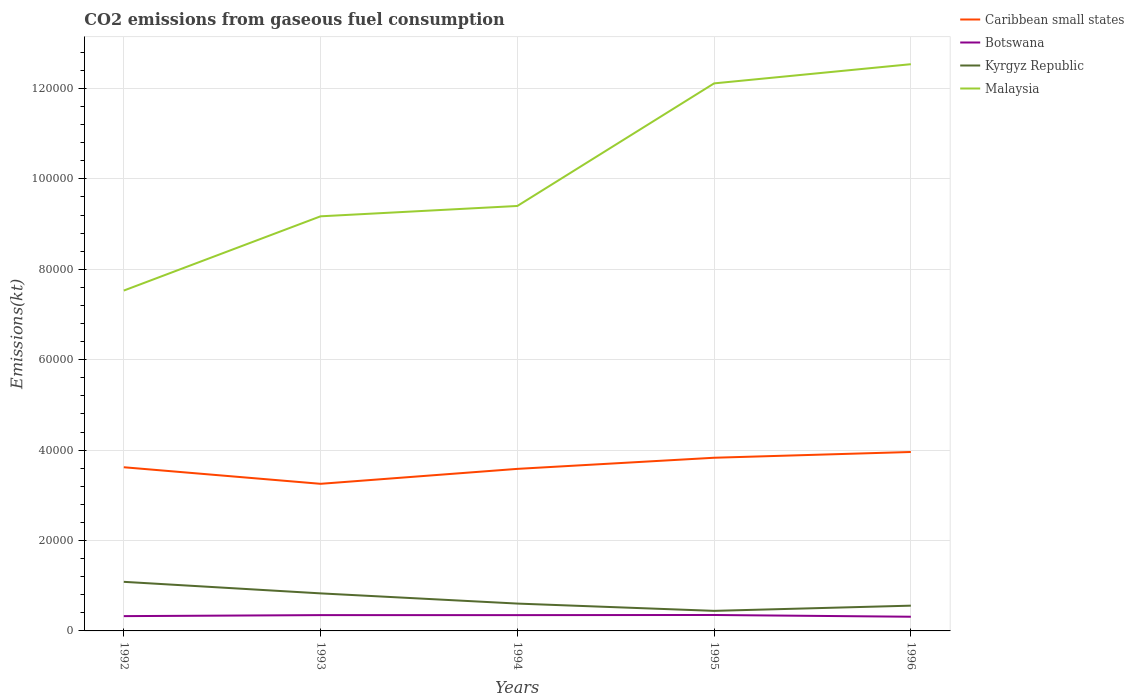How many different coloured lines are there?
Provide a succinct answer. 4. Is the number of lines equal to the number of legend labels?
Offer a terse response. Yes. Across all years, what is the maximum amount of CO2 emitted in Botswana?
Provide a short and direct response. 3138.95. What is the total amount of CO2 emitted in Botswana in the graph?
Provide a succinct answer. -25.67. What is the difference between the highest and the second highest amount of CO2 emitted in Kyrgyz Republic?
Your response must be concise. 6424.58. How many lines are there?
Offer a very short reply. 4. Does the graph contain any zero values?
Your answer should be very brief. No. Does the graph contain grids?
Ensure brevity in your answer.  Yes. Where does the legend appear in the graph?
Your answer should be very brief. Top right. How are the legend labels stacked?
Offer a terse response. Vertical. What is the title of the graph?
Keep it short and to the point. CO2 emissions from gaseous fuel consumption. What is the label or title of the Y-axis?
Give a very brief answer. Emissions(kt). What is the Emissions(kt) of Caribbean small states in 1992?
Your response must be concise. 3.62e+04. What is the Emissions(kt) in Botswana in 1992?
Make the answer very short. 3274.63. What is the Emissions(kt) in Kyrgyz Republic in 1992?
Offer a very short reply. 1.09e+04. What is the Emissions(kt) in Malaysia in 1992?
Offer a terse response. 7.53e+04. What is the Emissions(kt) in Caribbean small states in 1993?
Provide a short and direct response. 3.25e+04. What is the Emissions(kt) of Botswana in 1993?
Provide a short and direct response. 3498.32. What is the Emissions(kt) in Kyrgyz Republic in 1993?
Offer a terse response. 8305.75. What is the Emissions(kt) of Malaysia in 1993?
Your response must be concise. 9.17e+04. What is the Emissions(kt) in Caribbean small states in 1994?
Provide a short and direct response. 3.58e+04. What is the Emissions(kt) of Botswana in 1994?
Keep it short and to the point. 3494.65. What is the Emissions(kt) of Kyrgyz Republic in 1994?
Give a very brief answer. 6050.55. What is the Emissions(kt) of Malaysia in 1994?
Provide a short and direct response. 9.40e+04. What is the Emissions(kt) of Caribbean small states in 1995?
Your answer should be compact. 3.83e+04. What is the Emissions(kt) of Botswana in 1995?
Provide a short and direct response. 3523.99. What is the Emissions(kt) of Kyrgyz Republic in 1995?
Ensure brevity in your answer.  4437.07. What is the Emissions(kt) of Malaysia in 1995?
Provide a short and direct response. 1.21e+05. What is the Emissions(kt) of Caribbean small states in 1996?
Keep it short and to the point. 3.96e+04. What is the Emissions(kt) of Botswana in 1996?
Provide a short and direct response. 3138.95. What is the Emissions(kt) of Kyrgyz Republic in 1996?
Your answer should be compact. 5588.51. What is the Emissions(kt) in Malaysia in 1996?
Your answer should be very brief. 1.25e+05. Across all years, what is the maximum Emissions(kt) of Caribbean small states?
Give a very brief answer. 3.96e+04. Across all years, what is the maximum Emissions(kt) of Botswana?
Your response must be concise. 3523.99. Across all years, what is the maximum Emissions(kt) of Kyrgyz Republic?
Offer a terse response. 1.09e+04. Across all years, what is the maximum Emissions(kt) in Malaysia?
Your response must be concise. 1.25e+05. Across all years, what is the minimum Emissions(kt) in Caribbean small states?
Your answer should be compact. 3.25e+04. Across all years, what is the minimum Emissions(kt) of Botswana?
Provide a short and direct response. 3138.95. Across all years, what is the minimum Emissions(kt) of Kyrgyz Republic?
Offer a terse response. 4437.07. Across all years, what is the minimum Emissions(kt) in Malaysia?
Your response must be concise. 7.53e+04. What is the total Emissions(kt) of Caribbean small states in the graph?
Give a very brief answer. 1.82e+05. What is the total Emissions(kt) of Botswana in the graph?
Your answer should be very brief. 1.69e+04. What is the total Emissions(kt) of Kyrgyz Republic in the graph?
Provide a succinct answer. 3.52e+04. What is the total Emissions(kt) of Malaysia in the graph?
Make the answer very short. 5.08e+05. What is the difference between the Emissions(kt) in Caribbean small states in 1992 and that in 1993?
Ensure brevity in your answer.  3663.33. What is the difference between the Emissions(kt) of Botswana in 1992 and that in 1993?
Keep it short and to the point. -223.69. What is the difference between the Emissions(kt) in Kyrgyz Republic in 1992 and that in 1993?
Offer a very short reply. 2555.9. What is the difference between the Emissions(kt) in Malaysia in 1992 and that in 1993?
Keep it short and to the point. -1.64e+04. What is the difference between the Emissions(kt) of Caribbean small states in 1992 and that in 1994?
Provide a short and direct response. 359.37. What is the difference between the Emissions(kt) in Botswana in 1992 and that in 1994?
Provide a short and direct response. -220.02. What is the difference between the Emissions(kt) of Kyrgyz Republic in 1992 and that in 1994?
Your response must be concise. 4811.1. What is the difference between the Emissions(kt) of Malaysia in 1992 and that in 1994?
Your response must be concise. -1.87e+04. What is the difference between the Emissions(kt) of Caribbean small states in 1992 and that in 1995?
Give a very brief answer. -2101.19. What is the difference between the Emissions(kt) in Botswana in 1992 and that in 1995?
Provide a short and direct response. -249.36. What is the difference between the Emissions(kt) in Kyrgyz Republic in 1992 and that in 1995?
Make the answer very short. 6424.58. What is the difference between the Emissions(kt) of Malaysia in 1992 and that in 1995?
Your answer should be compact. -4.58e+04. What is the difference between the Emissions(kt) in Caribbean small states in 1992 and that in 1996?
Offer a very short reply. -3377.31. What is the difference between the Emissions(kt) of Botswana in 1992 and that in 1996?
Make the answer very short. 135.68. What is the difference between the Emissions(kt) of Kyrgyz Republic in 1992 and that in 1996?
Offer a very short reply. 5273.15. What is the difference between the Emissions(kt) of Malaysia in 1992 and that in 1996?
Make the answer very short. -5.01e+04. What is the difference between the Emissions(kt) of Caribbean small states in 1993 and that in 1994?
Offer a very short reply. -3303.97. What is the difference between the Emissions(kt) of Botswana in 1993 and that in 1994?
Give a very brief answer. 3.67. What is the difference between the Emissions(kt) of Kyrgyz Republic in 1993 and that in 1994?
Provide a succinct answer. 2255.2. What is the difference between the Emissions(kt) of Malaysia in 1993 and that in 1994?
Your answer should be very brief. -2288.21. What is the difference between the Emissions(kt) in Caribbean small states in 1993 and that in 1995?
Provide a succinct answer. -5764.52. What is the difference between the Emissions(kt) of Botswana in 1993 and that in 1995?
Provide a succinct answer. -25.67. What is the difference between the Emissions(kt) in Kyrgyz Republic in 1993 and that in 1995?
Provide a short and direct response. 3868.68. What is the difference between the Emissions(kt) of Malaysia in 1993 and that in 1995?
Your answer should be very brief. -2.94e+04. What is the difference between the Emissions(kt) in Caribbean small states in 1993 and that in 1996?
Provide a short and direct response. -7040.64. What is the difference between the Emissions(kt) in Botswana in 1993 and that in 1996?
Your answer should be compact. 359.37. What is the difference between the Emissions(kt) in Kyrgyz Republic in 1993 and that in 1996?
Your answer should be very brief. 2717.25. What is the difference between the Emissions(kt) in Malaysia in 1993 and that in 1996?
Offer a very short reply. -3.37e+04. What is the difference between the Emissions(kt) of Caribbean small states in 1994 and that in 1995?
Keep it short and to the point. -2460.56. What is the difference between the Emissions(kt) of Botswana in 1994 and that in 1995?
Offer a very short reply. -29.34. What is the difference between the Emissions(kt) in Kyrgyz Republic in 1994 and that in 1995?
Your response must be concise. 1613.48. What is the difference between the Emissions(kt) in Malaysia in 1994 and that in 1995?
Your answer should be very brief. -2.71e+04. What is the difference between the Emissions(kt) of Caribbean small states in 1994 and that in 1996?
Provide a short and direct response. -3736.67. What is the difference between the Emissions(kt) of Botswana in 1994 and that in 1996?
Keep it short and to the point. 355.7. What is the difference between the Emissions(kt) in Kyrgyz Republic in 1994 and that in 1996?
Keep it short and to the point. 462.04. What is the difference between the Emissions(kt) of Malaysia in 1994 and that in 1996?
Keep it short and to the point. -3.14e+04. What is the difference between the Emissions(kt) of Caribbean small states in 1995 and that in 1996?
Your answer should be very brief. -1276.12. What is the difference between the Emissions(kt) in Botswana in 1995 and that in 1996?
Provide a succinct answer. 385.04. What is the difference between the Emissions(kt) in Kyrgyz Republic in 1995 and that in 1996?
Provide a short and direct response. -1151.44. What is the difference between the Emissions(kt) of Malaysia in 1995 and that in 1996?
Provide a short and direct response. -4242.72. What is the difference between the Emissions(kt) in Caribbean small states in 1992 and the Emissions(kt) in Botswana in 1993?
Ensure brevity in your answer.  3.27e+04. What is the difference between the Emissions(kt) in Caribbean small states in 1992 and the Emissions(kt) in Kyrgyz Republic in 1993?
Offer a very short reply. 2.79e+04. What is the difference between the Emissions(kt) in Caribbean small states in 1992 and the Emissions(kt) in Malaysia in 1993?
Provide a short and direct response. -5.55e+04. What is the difference between the Emissions(kt) of Botswana in 1992 and the Emissions(kt) of Kyrgyz Republic in 1993?
Provide a succinct answer. -5031.12. What is the difference between the Emissions(kt) in Botswana in 1992 and the Emissions(kt) in Malaysia in 1993?
Make the answer very short. -8.84e+04. What is the difference between the Emissions(kt) in Kyrgyz Republic in 1992 and the Emissions(kt) in Malaysia in 1993?
Provide a short and direct response. -8.09e+04. What is the difference between the Emissions(kt) of Caribbean small states in 1992 and the Emissions(kt) of Botswana in 1994?
Offer a very short reply. 3.27e+04. What is the difference between the Emissions(kt) in Caribbean small states in 1992 and the Emissions(kt) in Kyrgyz Republic in 1994?
Your answer should be compact. 3.02e+04. What is the difference between the Emissions(kt) of Caribbean small states in 1992 and the Emissions(kt) of Malaysia in 1994?
Your response must be concise. -5.78e+04. What is the difference between the Emissions(kt) in Botswana in 1992 and the Emissions(kt) in Kyrgyz Republic in 1994?
Give a very brief answer. -2775.92. What is the difference between the Emissions(kt) of Botswana in 1992 and the Emissions(kt) of Malaysia in 1994?
Ensure brevity in your answer.  -9.07e+04. What is the difference between the Emissions(kt) in Kyrgyz Republic in 1992 and the Emissions(kt) in Malaysia in 1994?
Make the answer very short. -8.31e+04. What is the difference between the Emissions(kt) of Caribbean small states in 1992 and the Emissions(kt) of Botswana in 1995?
Keep it short and to the point. 3.27e+04. What is the difference between the Emissions(kt) of Caribbean small states in 1992 and the Emissions(kt) of Kyrgyz Republic in 1995?
Provide a succinct answer. 3.18e+04. What is the difference between the Emissions(kt) in Caribbean small states in 1992 and the Emissions(kt) in Malaysia in 1995?
Offer a terse response. -8.49e+04. What is the difference between the Emissions(kt) of Botswana in 1992 and the Emissions(kt) of Kyrgyz Republic in 1995?
Give a very brief answer. -1162.44. What is the difference between the Emissions(kt) in Botswana in 1992 and the Emissions(kt) in Malaysia in 1995?
Ensure brevity in your answer.  -1.18e+05. What is the difference between the Emissions(kt) of Kyrgyz Republic in 1992 and the Emissions(kt) of Malaysia in 1995?
Make the answer very short. -1.10e+05. What is the difference between the Emissions(kt) in Caribbean small states in 1992 and the Emissions(kt) in Botswana in 1996?
Your answer should be very brief. 3.31e+04. What is the difference between the Emissions(kt) of Caribbean small states in 1992 and the Emissions(kt) of Kyrgyz Republic in 1996?
Your response must be concise. 3.06e+04. What is the difference between the Emissions(kt) in Caribbean small states in 1992 and the Emissions(kt) in Malaysia in 1996?
Your answer should be very brief. -8.92e+04. What is the difference between the Emissions(kt) in Botswana in 1992 and the Emissions(kt) in Kyrgyz Republic in 1996?
Provide a short and direct response. -2313.88. What is the difference between the Emissions(kt) in Botswana in 1992 and the Emissions(kt) in Malaysia in 1996?
Ensure brevity in your answer.  -1.22e+05. What is the difference between the Emissions(kt) in Kyrgyz Republic in 1992 and the Emissions(kt) in Malaysia in 1996?
Offer a terse response. -1.15e+05. What is the difference between the Emissions(kt) in Caribbean small states in 1993 and the Emissions(kt) in Botswana in 1994?
Offer a very short reply. 2.90e+04. What is the difference between the Emissions(kt) in Caribbean small states in 1993 and the Emissions(kt) in Kyrgyz Republic in 1994?
Ensure brevity in your answer.  2.65e+04. What is the difference between the Emissions(kt) in Caribbean small states in 1993 and the Emissions(kt) in Malaysia in 1994?
Give a very brief answer. -6.15e+04. What is the difference between the Emissions(kt) of Botswana in 1993 and the Emissions(kt) of Kyrgyz Republic in 1994?
Provide a short and direct response. -2552.23. What is the difference between the Emissions(kt) of Botswana in 1993 and the Emissions(kt) of Malaysia in 1994?
Make the answer very short. -9.05e+04. What is the difference between the Emissions(kt) of Kyrgyz Republic in 1993 and the Emissions(kt) of Malaysia in 1994?
Your response must be concise. -8.57e+04. What is the difference between the Emissions(kt) in Caribbean small states in 1993 and the Emissions(kt) in Botswana in 1995?
Make the answer very short. 2.90e+04. What is the difference between the Emissions(kt) of Caribbean small states in 1993 and the Emissions(kt) of Kyrgyz Republic in 1995?
Keep it short and to the point. 2.81e+04. What is the difference between the Emissions(kt) of Caribbean small states in 1993 and the Emissions(kt) of Malaysia in 1995?
Keep it short and to the point. -8.86e+04. What is the difference between the Emissions(kt) of Botswana in 1993 and the Emissions(kt) of Kyrgyz Republic in 1995?
Your answer should be compact. -938.75. What is the difference between the Emissions(kt) in Botswana in 1993 and the Emissions(kt) in Malaysia in 1995?
Your answer should be compact. -1.18e+05. What is the difference between the Emissions(kt) of Kyrgyz Republic in 1993 and the Emissions(kt) of Malaysia in 1995?
Make the answer very short. -1.13e+05. What is the difference between the Emissions(kt) in Caribbean small states in 1993 and the Emissions(kt) in Botswana in 1996?
Your answer should be very brief. 2.94e+04. What is the difference between the Emissions(kt) of Caribbean small states in 1993 and the Emissions(kt) of Kyrgyz Republic in 1996?
Your answer should be compact. 2.70e+04. What is the difference between the Emissions(kt) in Caribbean small states in 1993 and the Emissions(kt) in Malaysia in 1996?
Offer a terse response. -9.28e+04. What is the difference between the Emissions(kt) in Botswana in 1993 and the Emissions(kt) in Kyrgyz Republic in 1996?
Make the answer very short. -2090.19. What is the difference between the Emissions(kt) of Botswana in 1993 and the Emissions(kt) of Malaysia in 1996?
Provide a short and direct response. -1.22e+05. What is the difference between the Emissions(kt) in Kyrgyz Republic in 1993 and the Emissions(kt) in Malaysia in 1996?
Your response must be concise. -1.17e+05. What is the difference between the Emissions(kt) of Caribbean small states in 1994 and the Emissions(kt) of Botswana in 1995?
Make the answer very short. 3.23e+04. What is the difference between the Emissions(kt) of Caribbean small states in 1994 and the Emissions(kt) of Kyrgyz Republic in 1995?
Offer a very short reply. 3.14e+04. What is the difference between the Emissions(kt) in Caribbean small states in 1994 and the Emissions(kt) in Malaysia in 1995?
Provide a succinct answer. -8.53e+04. What is the difference between the Emissions(kt) of Botswana in 1994 and the Emissions(kt) of Kyrgyz Republic in 1995?
Give a very brief answer. -942.42. What is the difference between the Emissions(kt) in Botswana in 1994 and the Emissions(kt) in Malaysia in 1995?
Offer a terse response. -1.18e+05. What is the difference between the Emissions(kt) in Kyrgyz Republic in 1994 and the Emissions(kt) in Malaysia in 1995?
Offer a terse response. -1.15e+05. What is the difference between the Emissions(kt) of Caribbean small states in 1994 and the Emissions(kt) of Botswana in 1996?
Give a very brief answer. 3.27e+04. What is the difference between the Emissions(kt) of Caribbean small states in 1994 and the Emissions(kt) of Kyrgyz Republic in 1996?
Your answer should be very brief. 3.03e+04. What is the difference between the Emissions(kt) of Caribbean small states in 1994 and the Emissions(kt) of Malaysia in 1996?
Offer a terse response. -8.95e+04. What is the difference between the Emissions(kt) of Botswana in 1994 and the Emissions(kt) of Kyrgyz Republic in 1996?
Ensure brevity in your answer.  -2093.86. What is the difference between the Emissions(kt) in Botswana in 1994 and the Emissions(kt) in Malaysia in 1996?
Your response must be concise. -1.22e+05. What is the difference between the Emissions(kt) in Kyrgyz Republic in 1994 and the Emissions(kt) in Malaysia in 1996?
Give a very brief answer. -1.19e+05. What is the difference between the Emissions(kt) in Caribbean small states in 1995 and the Emissions(kt) in Botswana in 1996?
Ensure brevity in your answer.  3.52e+04. What is the difference between the Emissions(kt) in Caribbean small states in 1995 and the Emissions(kt) in Kyrgyz Republic in 1996?
Offer a terse response. 3.27e+04. What is the difference between the Emissions(kt) in Caribbean small states in 1995 and the Emissions(kt) in Malaysia in 1996?
Offer a very short reply. -8.71e+04. What is the difference between the Emissions(kt) in Botswana in 1995 and the Emissions(kt) in Kyrgyz Republic in 1996?
Your answer should be very brief. -2064.52. What is the difference between the Emissions(kt) in Botswana in 1995 and the Emissions(kt) in Malaysia in 1996?
Offer a very short reply. -1.22e+05. What is the difference between the Emissions(kt) in Kyrgyz Republic in 1995 and the Emissions(kt) in Malaysia in 1996?
Ensure brevity in your answer.  -1.21e+05. What is the average Emissions(kt) in Caribbean small states per year?
Your answer should be compact. 3.65e+04. What is the average Emissions(kt) in Botswana per year?
Your answer should be very brief. 3386.11. What is the average Emissions(kt) of Kyrgyz Republic per year?
Offer a very short reply. 7048.71. What is the average Emissions(kt) in Malaysia per year?
Keep it short and to the point. 1.02e+05. In the year 1992, what is the difference between the Emissions(kt) in Caribbean small states and Emissions(kt) in Botswana?
Provide a short and direct response. 3.29e+04. In the year 1992, what is the difference between the Emissions(kt) in Caribbean small states and Emissions(kt) in Kyrgyz Republic?
Offer a very short reply. 2.53e+04. In the year 1992, what is the difference between the Emissions(kt) of Caribbean small states and Emissions(kt) of Malaysia?
Make the answer very short. -3.91e+04. In the year 1992, what is the difference between the Emissions(kt) in Botswana and Emissions(kt) in Kyrgyz Republic?
Your answer should be compact. -7587.02. In the year 1992, what is the difference between the Emissions(kt) in Botswana and Emissions(kt) in Malaysia?
Offer a very short reply. -7.20e+04. In the year 1992, what is the difference between the Emissions(kt) of Kyrgyz Republic and Emissions(kt) of Malaysia?
Keep it short and to the point. -6.44e+04. In the year 1993, what is the difference between the Emissions(kt) in Caribbean small states and Emissions(kt) in Botswana?
Provide a succinct answer. 2.90e+04. In the year 1993, what is the difference between the Emissions(kt) of Caribbean small states and Emissions(kt) of Kyrgyz Republic?
Give a very brief answer. 2.42e+04. In the year 1993, what is the difference between the Emissions(kt) in Caribbean small states and Emissions(kt) in Malaysia?
Make the answer very short. -5.92e+04. In the year 1993, what is the difference between the Emissions(kt) in Botswana and Emissions(kt) in Kyrgyz Republic?
Keep it short and to the point. -4807.44. In the year 1993, what is the difference between the Emissions(kt) of Botswana and Emissions(kt) of Malaysia?
Provide a succinct answer. -8.82e+04. In the year 1993, what is the difference between the Emissions(kt) in Kyrgyz Republic and Emissions(kt) in Malaysia?
Make the answer very short. -8.34e+04. In the year 1994, what is the difference between the Emissions(kt) in Caribbean small states and Emissions(kt) in Botswana?
Give a very brief answer. 3.24e+04. In the year 1994, what is the difference between the Emissions(kt) in Caribbean small states and Emissions(kt) in Kyrgyz Republic?
Offer a terse response. 2.98e+04. In the year 1994, what is the difference between the Emissions(kt) in Caribbean small states and Emissions(kt) in Malaysia?
Offer a terse response. -5.82e+04. In the year 1994, what is the difference between the Emissions(kt) of Botswana and Emissions(kt) of Kyrgyz Republic?
Offer a very short reply. -2555.9. In the year 1994, what is the difference between the Emissions(kt) of Botswana and Emissions(kt) of Malaysia?
Your answer should be compact. -9.05e+04. In the year 1994, what is the difference between the Emissions(kt) in Kyrgyz Republic and Emissions(kt) in Malaysia?
Your response must be concise. -8.80e+04. In the year 1995, what is the difference between the Emissions(kt) in Caribbean small states and Emissions(kt) in Botswana?
Give a very brief answer. 3.48e+04. In the year 1995, what is the difference between the Emissions(kt) of Caribbean small states and Emissions(kt) of Kyrgyz Republic?
Ensure brevity in your answer.  3.39e+04. In the year 1995, what is the difference between the Emissions(kt) in Caribbean small states and Emissions(kt) in Malaysia?
Your response must be concise. -8.28e+04. In the year 1995, what is the difference between the Emissions(kt) of Botswana and Emissions(kt) of Kyrgyz Republic?
Give a very brief answer. -913.08. In the year 1995, what is the difference between the Emissions(kt) in Botswana and Emissions(kt) in Malaysia?
Your answer should be very brief. -1.18e+05. In the year 1995, what is the difference between the Emissions(kt) of Kyrgyz Republic and Emissions(kt) of Malaysia?
Offer a very short reply. -1.17e+05. In the year 1996, what is the difference between the Emissions(kt) of Caribbean small states and Emissions(kt) of Botswana?
Offer a terse response. 3.64e+04. In the year 1996, what is the difference between the Emissions(kt) in Caribbean small states and Emissions(kt) in Kyrgyz Republic?
Provide a succinct answer. 3.40e+04. In the year 1996, what is the difference between the Emissions(kt) in Caribbean small states and Emissions(kt) in Malaysia?
Your answer should be compact. -8.58e+04. In the year 1996, what is the difference between the Emissions(kt) of Botswana and Emissions(kt) of Kyrgyz Republic?
Offer a very short reply. -2449.56. In the year 1996, what is the difference between the Emissions(kt) in Botswana and Emissions(kt) in Malaysia?
Provide a succinct answer. -1.22e+05. In the year 1996, what is the difference between the Emissions(kt) in Kyrgyz Republic and Emissions(kt) in Malaysia?
Provide a short and direct response. -1.20e+05. What is the ratio of the Emissions(kt) in Caribbean small states in 1992 to that in 1993?
Give a very brief answer. 1.11. What is the ratio of the Emissions(kt) in Botswana in 1992 to that in 1993?
Your response must be concise. 0.94. What is the ratio of the Emissions(kt) in Kyrgyz Republic in 1992 to that in 1993?
Your response must be concise. 1.31. What is the ratio of the Emissions(kt) of Malaysia in 1992 to that in 1993?
Offer a terse response. 0.82. What is the ratio of the Emissions(kt) in Botswana in 1992 to that in 1994?
Provide a succinct answer. 0.94. What is the ratio of the Emissions(kt) of Kyrgyz Republic in 1992 to that in 1994?
Ensure brevity in your answer.  1.8. What is the ratio of the Emissions(kt) of Malaysia in 1992 to that in 1994?
Give a very brief answer. 0.8. What is the ratio of the Emissions(kt) in Caribbean small states in 1992 to that in 1995?
Give a very brief answer. 0.95. What is the ratio of the Emissions(kt) of Botswana in 1992 to that in 1995?
Give a very brief answer. 0.93. What is the ratio of the Emissions(kt) of Kyrgyz Republic in 1992 to that in 1995?
Offer a terse response. 2.45. What is the ratio of the Emissions(kt) in Malaysia in 1992 to that in 1995?
Give a very brief answer. 0.62. What is the ratio of the Emissions(kt) in Caribbean small states in 1992 to that in 1996?
Keep it short and to the point. 0.91. What is the ratio of the Emissions(kt) of Botswana in 1992 to that in 1996?
Give a very brief answer. 1.04. What is the ratio of the Emissions(kt) in Kyrgyz Republic in 1992 to that in 1996?
Ensure brevity in your answer.  1.94. What is the ratio of the Emissions(kt) in Malaysia in 1992 to that in 1996?
Provide a short and direct response. 0.6. What is the ratio of the Emissions(kt) in Caribbean small states in 1993 to that in 1994?
Your answer should be very brief. 0.91. What is the ratio of the Emissions(kt) in Botswana in 1993 to that in 1994?
Offer a terse response. 1. What is the ratio of the Emissions(kt) in Kyrgyz Republic in 1993 to that in 1994?
Offer a terse response. 1.37. What is the ratio of the Emissions(kt) of Malaysia in 1993 to that in 1994?
Offer a very short reply. 0.98. What is the ratio of the Emissions(kt) of Caribbean small states in 1993 to that in 1995?
Your answer should be very brief. 0.85. What is the ratio of the Emissions(kt) in Kyrgyz Republic in 1993 to that in 1995?
Provide a succinct answer. 1.87. What is the ratio of the Emissions(kt) in Malaysia in 1993 to that in 1995?
Keep it short and to the point. 0.76. What is the ratio of the Emissions(kt) of Caribbean small states in 1993 to that in 1996?
Provide a succinct answer. 0.82. What is the ratio of the Emissions(kt) of Botswana in 1993 to that in 1996?
Offer a very short reply. 1.11. What is the ratio of the Emissions(kt) of Kyrgyz Republic in 1993 to that in 1996?
Provide a succinct answer. 1.49. What is the ratio of the Emissions(kt) of Malaysia in 1993 to that in 1996?
Your response must be concise. 0.73. What is the ratio of the Emissions(kt) of Caribbean small states in 1994 to that in 1995?
Your answer should be compact. 0.94. What is the ratio of the Emissions(kt) of Botswana in 1994 to that in 1995?
Make the answer very short. 0.99. What is the ratio of the Emissions(kt) of Kyrgyz Republic in 1994 to that in 1995?
Ensure brevity in your answer.  1.36. What is the ratio of the Emissions(kt) of Malaysia in 1994 to that in 1995?
Keep it short and to the point. 0.78. What is the ratio of the Emissions(kt) in Caribbean small states in 1994 to that in 1996?
Keep it short and to the point. 0.91. What is the ratio of the Emissions(kt) in Botswana in 1994 to that in 1996?
Offer a very short reply. 1.11. What is the ratio of the Emissions(kt) of Kyrgyz Republic in 1994 to that in 1996?
Offer a very short reply. 1.08. What is the ratio of the Emissions(kt) in Malaysia in 1994 to that in 1996?
Offer a terse response. 0.75. What is the ratio of the Emissions(kt) in Caribbean small states in 1995 to that in 1996?
Give a very brief answer. 0.97. What is the ratio of the Emissions(kt) of Botswana in 1995 to that in 1996?
Your response must be concise. 1.12. What is the ratio of the Emissions(kt) of Kyrgyz Republic in 1995 to that in 1996?
Make the answer very short. 0.79. What is the ratio of the Emissions(kt) in Malaysia in 1995 to that in 1996?
Give a very brief answer. 0.97. What is the difference between the highest and the second highest Emissions(kt) in Caribbean small states?
Provide a succinct answer. 1276.12. What is the difference between the highest and the second highest Emissions(kt) in Botswana?
Offer a terse response. 25.67. What is the difference between the highest and the second highest Emissions(kt) of Kyrgyz Republic?
Provide a short and direct response. 2555.9. What is the difference between the highest and the second highest Emissions(kt) of Malaysia?
Provide a short and direct response. 4242.72. What is the difference between the highest and the lowest Emissions(kt) in Caribbean small states?
Ensure brevity in your answer.  7040.64. What is the difference between the highest and the lowest Emissions(kt) of Botswana?
Ensure brevity in your answer.  385.04. What is the difference between the highest and the lowest Emissions(kt) in Kyrgyz Republic?
Provide a short and direct response. 6424.58. What is the difference between the highest and the lowest Emissions(kt) of Malaysia?
Make the answer very short. 5.01e+04. 